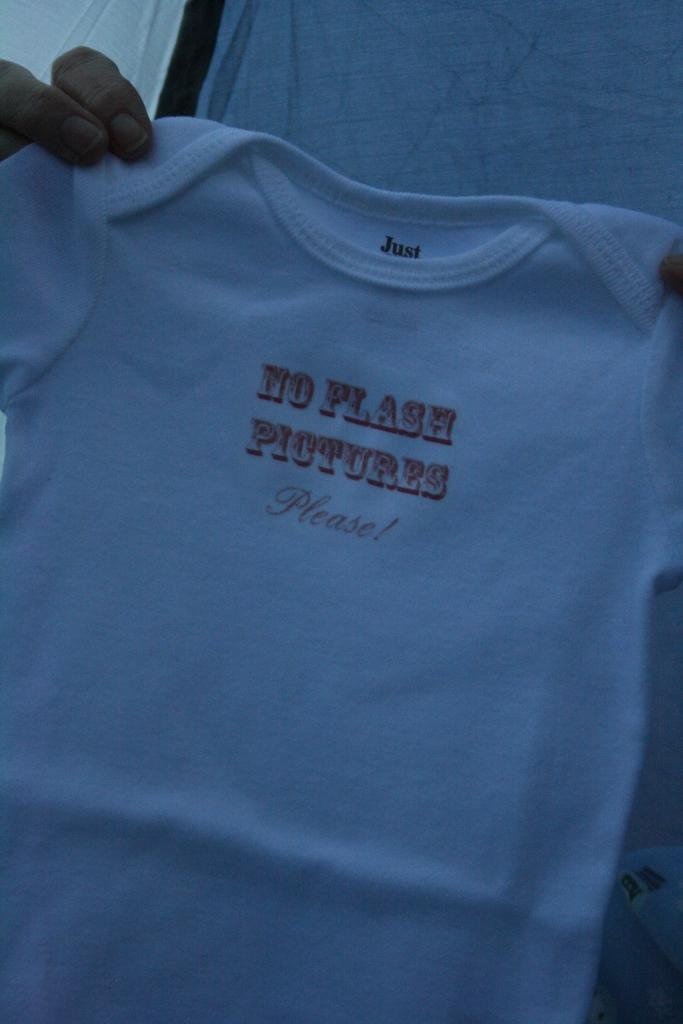<image>
Share a concise interpretation of the image provided. a small shirt that says 'no flash pictures please!' on it 